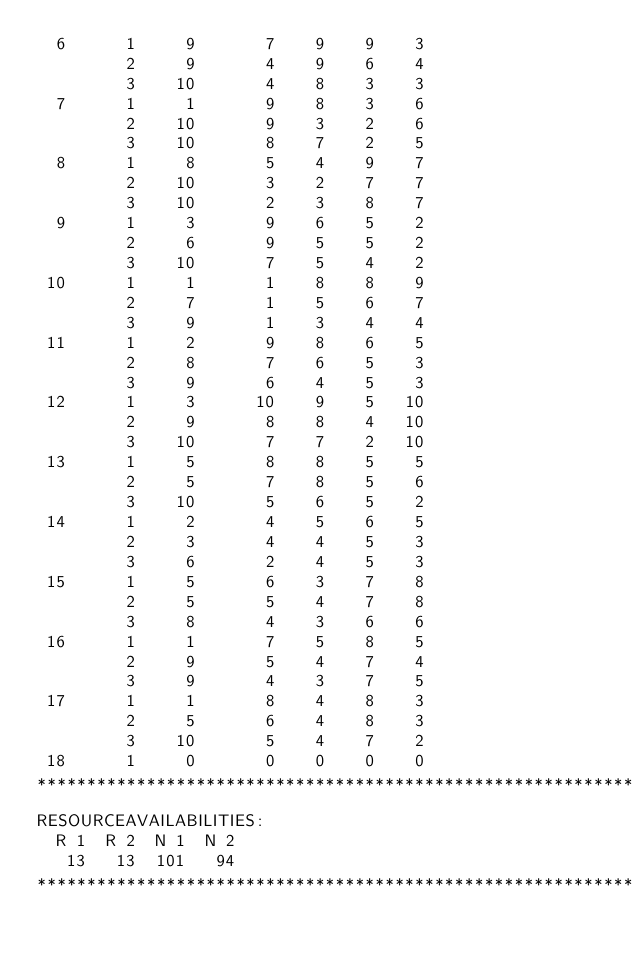<code> <loc_0><loc_0><loc_500><loc_500><_ObjectiveC_>  6      1     9       7    9    9    3
         2     9       4    9    6    4
         3    10       4    8    3    3
  7      1     1       9    8    3    6
         2    10       9    3    2    6
         3    10       8    7    2    5
  8      1     8       5    4    9    7
         2    10       3    2    7    7
         3    10       2    3    8    7
  9      1     3       9    6    5    2
         2     6       9    5    5    2
         3    10       7    5    4    2
 10      1     1       1    8    8    9
         2     7       1    5    6    7
         3     9       1    3    4    4
 11      1     2       9    8    6    5
         2     8       7    6    5    3
         3     9       6    4    5    3
 12      1     3      10    9    5   10
         2     9       8    8    4   10
         3    10       7    7    2   10
 13      1     5       8    8    5    5
         2     5       7    8    5    6
         3    10       5    6    5    2
 14      1     2       4    5    6    5
         2     3       4    4    5    3
         3     6       2    4    5    3
 15      1     5       6    3    7    8
         2     5       5    4    7    8
         3     8       4    3    6    6
 16      1     1       7    5    8    5
         2     9       5    4    7    4
         3     9       4    3    7    5
 17      1     1       8    4    8    3
         2     5       6    4    8    3
         3    10       5    4    7    2
 18      1     0       0    0    0    0
************************************************************************
RESOURCEAVAILABILITIES:
  R 1  R 2  N 1  N 2
   13   13  101   94
************************************************************************
</code> 